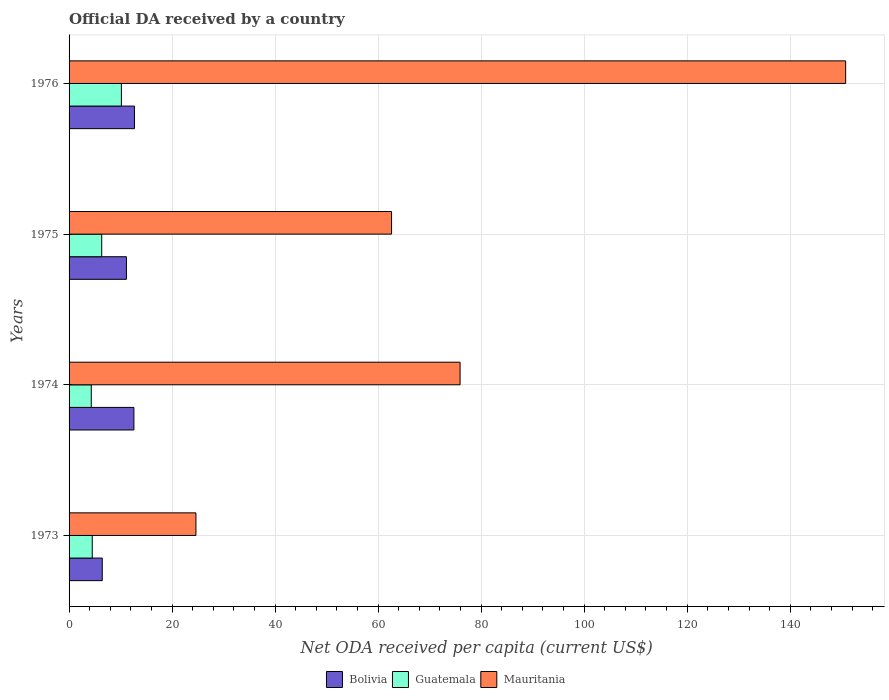How many different coloured bars are there?
Your answer should be very brief. 3. How many groups of bars are there?
Make the answer very short. 4. Are the number of bars on each tick of the Y-axis equal?
Your answer should be very brief. Yes. How many bars are there on the 3rd tick from the top?
Give a very brief answer. 3. How many bars are there on the 3rd tick from the bottom?
Ensure brevity in your answer.  3. What is the label of the 1st group of bars from the top?
Make the answer very short. 1976. What is the ODA received in in Guatemala in 1973?
Ensure brevity in your answer.  4.5. Across all years, what is the maximum ODA received in in Mauritania?
Make the answer very short. 150.76. Across all years, what is the minimum ODA received in in Mauritania?
Ensure brevity in your answer.  24.63. In which year was the ODA received in in Mauritania maximum?
Your response must be concise. 1976. In which year was the ODA received in in Guatemala minimum?
Offer a very short reply. 1974. What is the total ODA received in in Bolivia in the graph?
Keep it short and to the point. 42.87. What is the difference between the ODA received in in Guatemala in 1973 and that in 1974?
Ensure brevity in your answer.  0.19. What is the difference between the ODA received in in Bolivia in 1975 and the ODA received in in Mauritania in 1976?
Ensure brevity in your answer.  -139.63. What is the average ODA received in in Mauritania per year?
Your response must be concise. 78.48. In the year 1975, what is the difference between the ODA received in in Guatemala and ODA received in in Mauritania?
Your answer should be very brief. -56.26. In how many years, is the ODA received in in Mauritania greater than 96 US$?
Provide a short and direct response. 1. What is the ratio of the ODA received in in Bolivia in 1975 to that in 1976?
Keep it short and to the point. 0.88. Is the difference between the ODA received in in Guatemala in 1973 and 1975 greater than the difference between the ODA received in in Mauritania in 1973 and 1975?
Offer a very short reply. Yes. What is the difference between the highest and the second highest ODA received in in Bolivia?
Give a very brief answer. 0.11. What is the difference between the highest and the lowest ODA received in in Bolivia?
Ensure brevity in your answer.  6.25. Is the sum of the ODA received in in Bolivia in 1973 and 1975 greater than the maximum ODA received in in Mauritania across all years?
Provide a succinct answer. No. What does the 1st bar from the top in 1975 represents?
Your answer should be compact. Mauritania. What does the 2nd bar from the bottom in 1976 represents?
Keep it short and to the point. Guatemala. Is it the case that in every year, the sum of the ODA received in in Bolivia and ODA received in in Mauritania is greater than the ODA received in in Guatemala?
Your response must be concise. Yes. How many bars are there?
Make the answer very short. 12. What is the difference between two consecutive major ticks on the X-axis?
Provide a succinct answer. 20. Does the graph contain grids?
Keep it short and to the point. Yes. Where does the legend appear in the graph?
Your response must be concise. Bottom center. How many legend labels are there?
Your response must be concise. 3. What is the title of the graph?
Provide a short and direct response. Official DA received by a country. What is the label or title of the X-axis?
Provide a short and direct response. Net ODA received per capita (current US$). What is the Net ODA received per capita (current US$) in Bolivia in 1973?
Make the answer very short. 6.45. What is the Net ODA received per capita (current US$) in Guatemala in 1973?
Your answer should be very brief. 4.5. What is the Net ODA received per capita (current US$) of Mauritania in 1973?
Make the answer very short. 24.63. What is the Net ODA received per capita (current US$) in Bolivia in 1974?
Your answer should be compact. 12.59. What is the Net ODA received per capita (current US$) of Guatemala in 1974?
Your answer should be very brief. 4.31. What is the Net ODA received per capita (current US$) of Mauritania in 1974?
Ensure brevity in your answer.  75.91. What is the Net ODA received per capita (current US$) in Bolivia in 1975?
Offer a very short reply. 11.14. What is the Net ODA received per capita (current US$) of Guatemala in 1975?
Ensure brevity in your answer.  6.34. What is the Net ODA received per capita (current US$) in Mauritania in 1975?
Offer a very short reply. 62.6. What is the Net ODA received per capita (current US$) of Bolivia in 1976?
Your answer should be compact. 12.7. What is the Net ODA received per capita (current US$) in Guatemala in 1976?
Give a very brief answer. 10.16. What is the Net ODA received per capita (current US$) of Mauritania in 1976?
Keep it short and to the point. 150.76. Across all years, what is the maximum Net ODA received per capita (current US$) of Bolivia?
Offer a very short reply. 12.7. Across all years, what is the maximum Net ODA received per capita (current US$) in Guatemala?
Provide a short and direct response. 10.16. Across all years, what is the maximum Net ODA received per capita (current US$) in Mauritania?
Give a very brief answer. 150.76. Across all years, what is the minimum Net ODA received per capita (current US$) in Bolivia?
Make the answer very short. 6.45. Across all years, what is the minimum Net ODA received per capita (current US$) of Guatemala?
Make the answer very short. 4.31. Across all years, what is the minimum Net ODA received per capita (current US$) of Mauritania?
Keep it short and to the point. 24.63. What is the total Net ODA received per capita (current US$) of Bolivia in the graph?
Give a very brief answer. 42.87. What is the total Net ODA received per capita (current US$) in Guatemala in the graph?
Offer a very short reply. 25.3. What is the total Net ODA received per capita (current US$) in Mauritania in the graph?
Make the answer very short. 313.9. What is the difference between the Net ODA received per capita (current US$) in Bolivia in 1973 and that in 1974?
Keep it short and to the point. -6.14. What is the difference between the Net ODA received per capita (current US$) of Guatemala in 1973 and that in 1974?
Give a very brief answer. 0.19. What is the difference between the Net ODA received per capita (current US$) of Mauritania in 1973 and that in 1974?
Keep it short and to the point. -51.28. What is the difference between the Net ODA received per capita (current US$) in Bolivia in 1973 and that in 1975?
Provide a succinct answer. -4.69. What is the difference between the Net ODA received per capita (current US$) of Guatemala in 1973 and that in 1975?
Provide a short and direct response. -1.84. What is the difference between the Net ODA received per capita (current US$) in Mauritania in 1973 and that in 1975?
Your response must be concise. -37.97. What is the difference between the Net ODA received per capita (current US$) in Bolivia in 1973 and that in 1976?
Provide a short and direct response. -6.25. What is the difference between the Net ODA received per capita (current US$) of Guatemala in 1973 and that in 1976?
Provide a short and direct response. -5.66. What is the difference between the Net ODA received per capita (current US$) of Mauritania in 1973 and that in 1976?
Give a very brief answer. -126.14. What is the difference between the Net ODA received per capita (current US$) in Bolivia in 1974 and that in 1975?
Your answer should be compact. 1.45. What is the difference between the Net ODA received per capita (current US$) in Guatemala in 1974 and that in 1975?
Make the answer very short. -2.03. What is the difference between the Net ODA received per capita (current US$) in Mauritania in 1974 and that in 1975?
Your answer should be compact. 13.31. What is the difference between the Net ODA received per capita (current US$) of Bolivia in 1974 and that in 1976?
Your answer should be very brief. -0.11. What is the difference between the Net ODA received per capita (current US$) in Guatemala in 1974 and that in 1976?
Provide a succinct answer. -5.85. What is the difference between the Net ODA received per capita (current US$) in Mauritania in 1974 and that in 1976?
Keep it short and to the point. -74.85. What is the difference between the Net ODA received per capita (current US$) of Bolivia in 1975 and that in 1976?
Give a very brief answer. -1.56. What is the difference between the Net ODA received per capita (current US$) of Guatemala in 1975 and that in 1976?
Keep it short and to the point. -3.82. What is the difference between the Net ODA received per capita (current US$) in Mauritania in 1975 and that in 1976?
Your answer should be compact. -88.16. What is the difference between the Net ODA received per capita (current US$) of Bolivia in 1973 and the Net ODA received per capita (current US$) of Guatemala in 1974?
Offer a very short reply. 2.14. What is the difference between the Net ODA received per capita (current US$) of Bolivia in 1973 and the Net ODA received per capita (current US$) of Mauritania in 1974?
Make the answer very short. -69.46. What is the difference between the Net ODA received per capita (current US$) of Guatemala in 1973 and the Net ODA received per capita (current US$) of Mauritania in 1974?
Give a very brief answer. -71.41. What is the difference between the Net ODA received per capita (current US$) in Bolivia in 1973 and the Net ODA received per capita (current US$) in Guatemala in 1975?
Your answer should be very brief. 0.11. What is the difference between the Net ODA received per capita (current US$) in Bolivia in 1973 and the Net ODA received per capita (current US$) in Mauritania in 1975?
Offer a terse response. -56.16. What is the difference between the Net ODA received per capita (current US$) in Guatemala in 1973 and the Net ODA received per capita (current US$) in Mauritania in 1975?
Provide a succinct answer. -58.1. What is the difference between the Net ODA received per capita (current US$) in Bolivia in 1973 and the Net ODA received per capita (current US$) in Guatemala in 1976?
Provide a succinct answer. -3.71. What is the difference between the Net ODA received per capita (current US$) in Bolivia in 1973 and the Net ODA received per capita (current US$) in Mauritania in 1976?
Ensure brevity in your answer.  -144.32. What is the difference between the Net ODA received per capita (current US$) of Guatemala in 1973 and the Net ODA received per capita (current US$) of Mauritania in 1976?
Your answer should be compact. -146.26. What is the difference between the Net ODA received per capita (current US$) of Bolivia in 1974 and the Net ODA received per capita (current US$) of Guatemala in 1975?
Offer a terse response. 6.25. What is the difference between the Net ODA received per capita (current US$) in Bolivia in 1974 and the Net ODA received per capita (current US$) in Mauritania in 1975?
Offer a very short reply. -50.02. What is the difference between the Net ODA received per capita (current US$) of Guatemala in 1974 and the Net ODA received per capita (current US$) of Mauritania in 1975?
Provide a short and direct response. -58.29. What is the difference between the Net ODA received per capita (current US$) of Bolivia in 1974 and the Net ODA received per capita (current US$) of Guatemala in 1976?
Keep it short and to the point. 2.43. What is the difference between the Net ODA received per capita (current US$) in Bolivia in 1974 and the Net ODA received per capita (current US$) in Mauritania in 1976?
Your answer should be very brief. -138.18. What is the difference between the Net ODA received per capita (current US$) of Guatemala in 1974 and the Net ODA received per capita (current US$) of Mauritania in 1976?
Ensure brevity in your answer.  -146.45. What is the difference between the Net ODA received per capita (current US$) in Bolivia in 1975 and the Net ODA received per capita (current US$) in Guatemala in 1976?
Ensure brevity in your answer.  0.98. What is the difference between the Net ODA received per capita (current US$) of Bolivia in 1975 and the Net ODA received per capita (current US$) of Mauritania in 1976?
Offer a very short reply. -139.63. What is the difference between the Net ODA received per capita (current US$) in Guatemala in 1975 and the Net ODA received per capita (current US$) in Mauritania in 1976?
Your answer should be very brief. -144.42. What is the average Net ODA received per capita (current US$) of Bolivia per year?
Keep it short and to the point. 10.72. What is the average Net ODA received per capita (current US$) in Guatemala per year?
Offer a terse response. 6.33. What is the average Net ODA received per capita (current US$) of Mauritania per year?
Ensure brevity in your answer.  78.48. In the year 1973, what is the difference between the Net ODA received per capita (current US$) in Bolivia and Net ODA received per capita (current US$) in Guatemala?
Offer a terse response. 1.95. In the year 1973, what is the difference between the Net ODA received per capita (current US$) in Bolivia and Net ODA received per capita (current US$) in Mauritania?
Ensure brevity in your answer.  -18.18. In the year 1973, what is the difference between the Net ODA received per capita (current US$) of Guatemala and Net ODA received per capita (current US$) of Mauritania?
Offer a very short reply. -20.13. In the year 1974, what is the difference between the Net ODA received per capita (current US$) in Bolivia and Net ODA received per capita (current US$) in Guatemala?
Keep it short and to the point. 8.28. In the year 1974, what is the difference between the Net ODA received per capita (current US$) in Bolivia and Net ODA received per capita (current US$) in Mauritania?
Keep it short and to the point. -63.32. In the year 1974, what is the difference between the Net ODA received per capita (current US$) in Guatemala and Net ODA received per capita (current US$) in Mauritania?
Your answer should be very brief. -71.6. In the year 1975, what is the difference between the Net ODA received per capita (current US$) in Bolivia and Net ODA received per capita (current US$) in Guatemala?
Ensure brevity in your answer.  4.8. In the year 1975, what is the difference between the Net ODA received per capita (current US$) of Bolivia and Net ODA received per capita (current US$) of Mauritania?
Offer a terse response. -51.47. In the year 1975, what is the difference between the Net ODA received per capita (current US$) of Guatemala and Net ODA received per capita (current US$) of Mauritania?
Keep it short and to the point. -56.26. In the year 1976, what is the difference between the Net ODA received per capita (current US$) in Bolivia and Net ODA received per capita (current US$) in Guatemala?
Your response must be concise. 2.54. In the year 1976, what is the difference between the Net ODA received per capita (current US$) of Bolivia and Net ODA received per capita (current US$) of Mauritania?
Offer a terse response. -138.07. In the year 1976, what is the difference between the Net ODA received per capita (current US$) of Guatemala and Net ODA received per capita (current US$) of Mauritania?
Make the answer very short. -140.61. What is the ratio of the Net ODA received per capita (current US$) of Bolivia in 1973 to that in 1974?
Give a very brief answer. 0.51. What is the ratio of the Net ODA received per capita (current US$) of Guatemala in 1973 to that in 1974?
Make the answer very short. 1.04. What is the ratio of the Net ODA received per capita (current US$) of Mauritania in 1973 to that in 1974?
Keep it short and to the point. 0.32. What is the ratio of the Net ODA received per capita (current US$) in Bolivia in 1973 to that in 1975?
Provide a succinct answer. 0.58. What is the ratio of the Net ODA received per capita (current US$) in Guatemala in 1973 to that in 1975?
Keep it short and to the point. 0.71. What is the ratio of the Net ODA received per capita (current US$) in Mauritania in 1973 to that in 1975?
Give a very brief answer. 0.39. What is the ratio of the Net ODA received per capita (current US$) in Bolivia in 1973 to that in 1976?
Keep it short and to the point. 0.51. What is the ratio of the Net ODA received per capita (current US$) in Guatemala in 1973 to that in 1976?
Give a very brief answer. 0.44. What is the ratio of the Net ODA received per capita (current US$) in Mauritania in 1973 to that in 1976?
Provide a succinct answer. 0.16. What is the ratio of the Net ODA received per capita (current US$) in Bolivia in 1974 to that in 1975?
Offer a very short reply. 1.13. What is the ratio of the Net ODA received per capita (current US$) of Guatemala in 1974 to that in 1975?
Give a very brief answer. 0.68. What is the ratio of the Net ODA received per capita (current US$) in Mauritania in 1974 to that in 1975?
Your answer should be very brief. 1.21. What is the ratio of the Net ODA received per capita (current US$) in Guatemala in 1974 to that in 1976?
Offer a terse response. 0.42. What is the ratio of the Net ODA received per capita (current US$) in Mauritania in 1974 to that in 1976?
Offer a terse response. 0.5. What is the ratio of the Net ODA received per capita (current US$) of Bolivia in 1975 to that in 1976?
Your answer should be very brief. 0.88. What is the ratio of the Net ODA received per capita (current US$) of Guatemala in 1975 to that in 1976?
Offer a terse response. 0.62. What is the ratio of the Net ODA received per capita (current US$) in Mauritania in 1975 to that in 1976?
Provide a short and direct response. 0.42. What is the difference between the highest and the second highest Net ODA received per capita (current US$) of Bolivia?
Ensure brevity in your answer.  0.11. What is the difference between the highest and the second highest Net ODA received per capita (current US$) in Guatemala?
Your answer should be compact. 3.82. What is the difference between the highest and the second highest Net ODA received per capita (current US$) in Mauritania?
Provide a short and direct response. 74.85. What is the difference between the highest and the lowest Net ODA received per capita (current US$) in Bolivia?
Ensure brevity in your answer.  6.25. What is the difference between the highest and the lowest Net ODA received per capita (current US$) in Guatemala?
Give a very brief answer. 5.85. What is the difference between the highest and the lowest Net ODA received per capita (current US$) in Mauritania?
Provide a succinct answer. 126.14. 